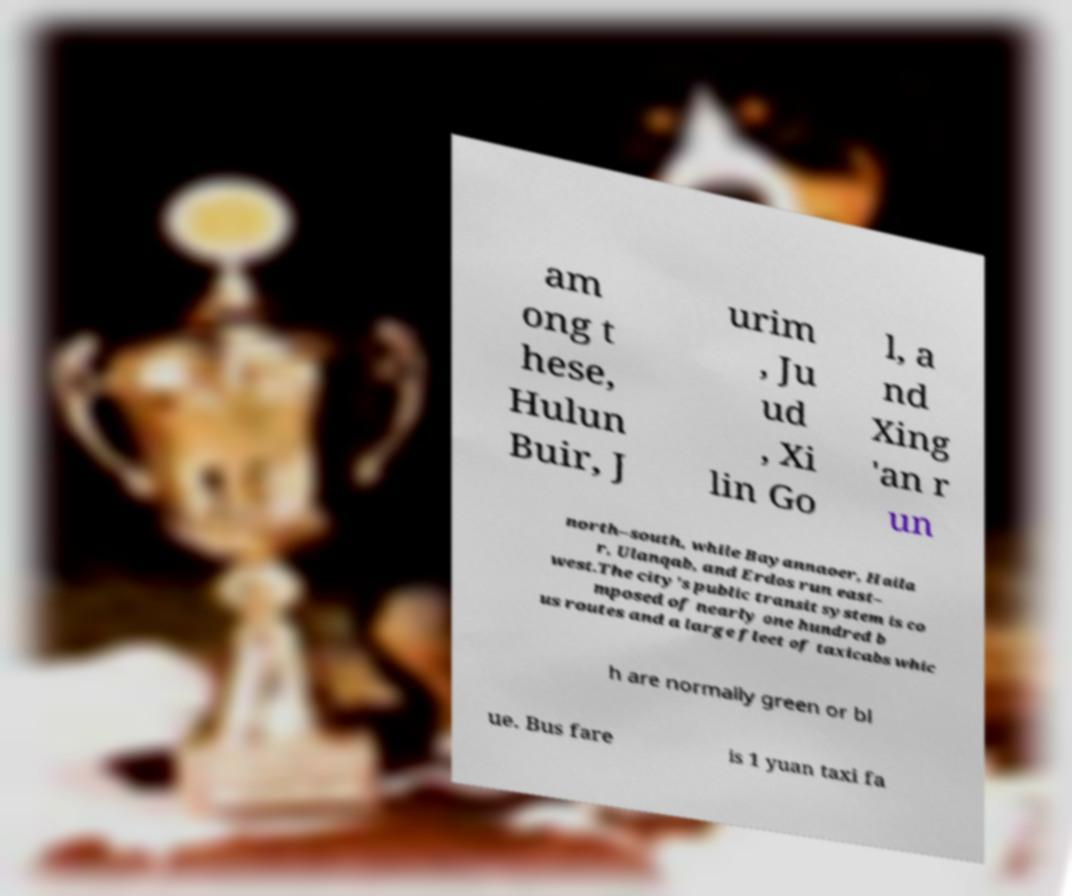Can you read and provide the text displayed in the image?This photo seems to have some interesting text. Can you extract and type it out for me? am ong t hese, Hulun Buir, J urim , Ju ud , Xi lin Go l, a nd Xing 'an r un north–south, while Bayannaoer, Haila r, Ulanqab, and Erdos run east– west.The city's public transit system is co mposed of nearly one hundred b us routes and a large fleet of taxicabs whic h are normally green or bl ue. Bus fare is 1 yuan taxi fa 